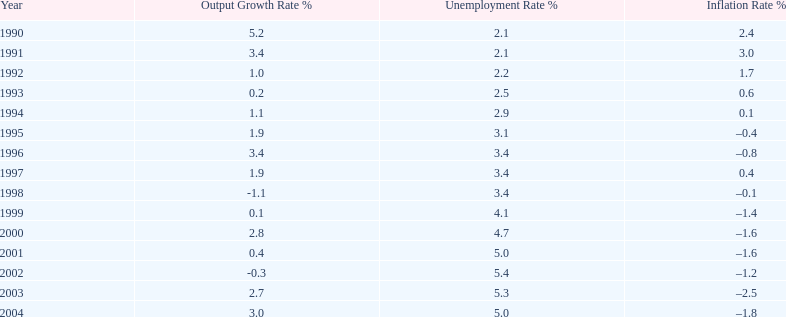What year saw the highest output growth rate in japan between the years 1990 and 2004? 1990. 